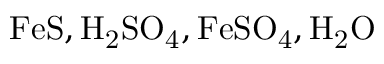<formula> <loc_0><loc_0><loc_500><loc_500>F e S , H _ { 2 } S O _ { 4 } , F e S O _ { 4 } , H _ { 2 } O</formula> 